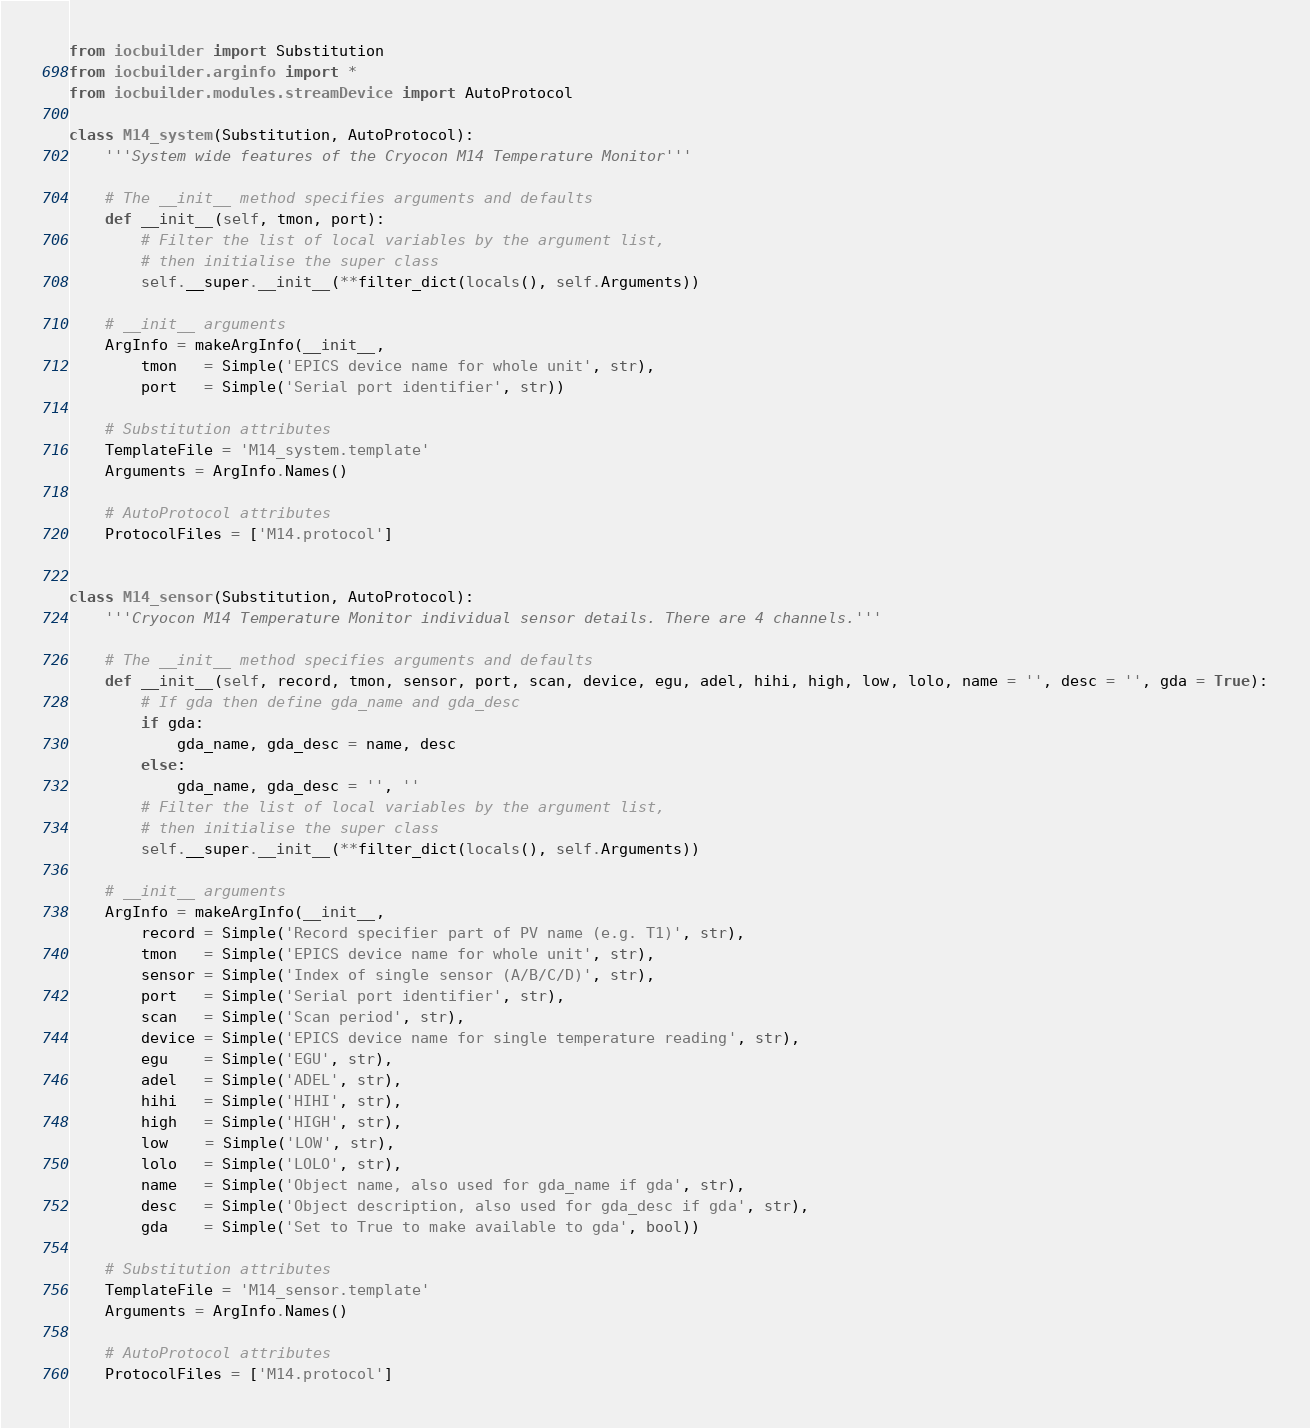<code> <loc_0><loc_0><loc_500><loc_500><_Python_>from iocbuilder import Substitution
from iocbuilder.arginfo import *
from iocbuilder.modules.streamDevice import AutoProtocol

class M14_system(Substitution, AutoProtocol):
    '''System wide features of the Cryocon M14 Temperature Monitor'''

    # The __init__ method specifies arguments and defaults
    def __init__(self, tmon, port):
        # Filter the list of local variables by the argument list,
        # then initialise the super class
        self.__super.__init__(**filter_dict(locals(), self.Arguments))

    # __init__ arguments
    ArgInfo = makeArgInfo(__init__,
        tmon   = Simple('EPICS device name for whole unit', str),
        port   = Simple('Serial port identifier', str))

    # Substitution attributes
    TemplateFile = 'M14_system.template'
    Arguments = ArgInfo.Names()

    # AutoProtocol attributes
    ProtocolFiles = ['M14.protocol']


class M14_sensor(Substitution, AutoProtocol):
    '''Cryocon M14 Temperature Monitor individual sensor details. There are 4 channels.'''

    # The __init__ method specifies arguments and defaults
    def __init__(self, record, tmon, sensor, port, scan, device, egu, adel, hihi, high, low, lolo, name = '', desc = '', gda = True):
        # If gda then define gda_name and gda_desc
        if gda:
            gda_name, gda_desc = name, desc
        else:
            gda_name, gda_desc = '', ''
        # Filter the list of local variables by the argument list,
        # then initialise the super class
        self.__super.__init__(**filter_dict(locals(), self.Arguments))

    # __init__ arguments
    ArgInfo = makeArgInfo(__init__,
        record = Simple('Record specifier part of PV name (e.g. T1)', str),
        tmon   = Simple('EPICS device name for whole unit', str),
        sensor = Simple('Index of single sensor (A/B/C/D)', str),
        port   = Simple('Serial port identifier', str),
        scan   = Simple('Scan period', str),
        device = Simple('EPICS device name for single temperature reading', str),
        egu    = Simple('EGU', str),
        adel   = Simple('ADEL', str),
        hihi   = Simple('HIHI', str),
        high   = Simple('HIGH', str),
        low    = Simple('LOW', str),
        lolo   = Simple('LOLO', str),
        name   = Simple('Object name, also used for gda_name if gda', str),
        desc   = Simple('Object description, also used for gda_desc if gda', str),
        gda    = Simple('Set to True to make available to gda', bool))

    # Substitution attributes
    TemplateFile = 'M14_sensor.template'
    Arguments = ArgInfo.Names()

    # AutoProtocol attributes
    ProtocolFiles = ['M14.protocol']


</code> 